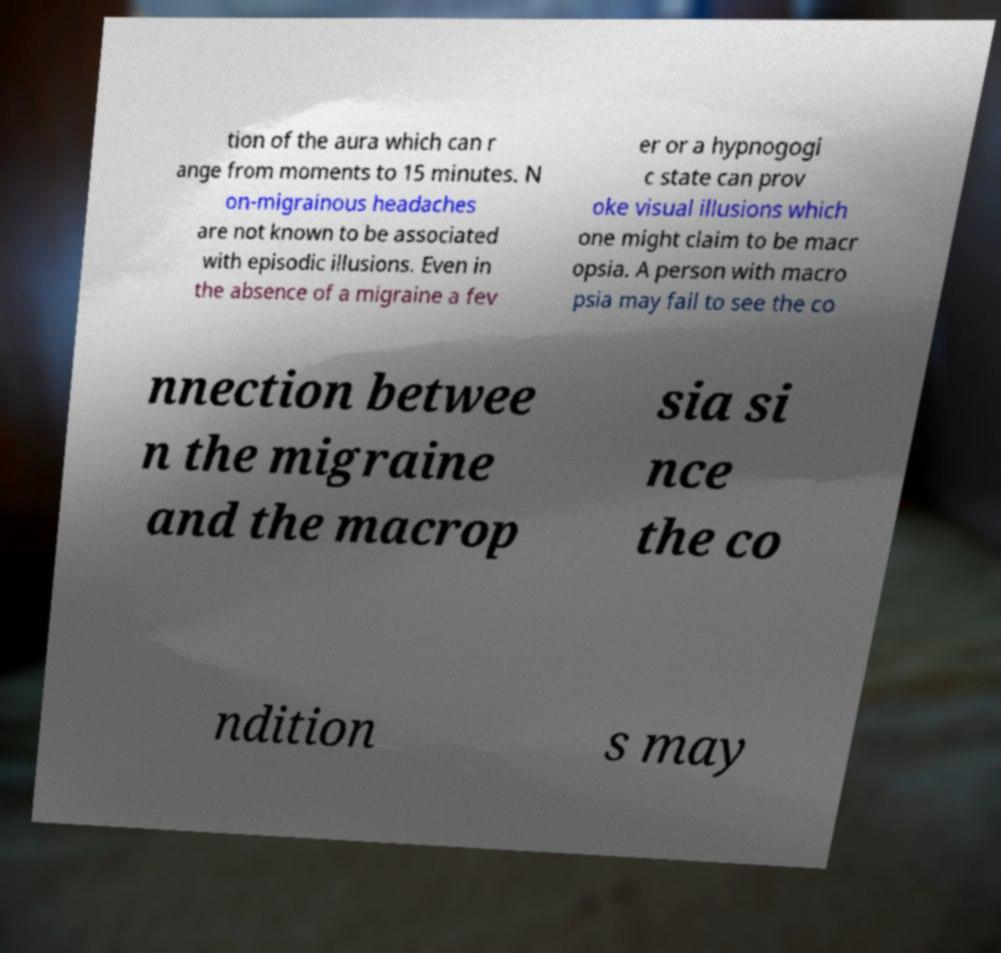Can you accurately transcribe the text from the provided image for me? tion of the aura which can r ange from moments to 15 minutes. N on-migrainous headaches are not known to be associated with episodic illusions. Even in the absence of a migraine a fev er or a hypnogogi c state can prov oke visual illusions which one might claim to be macr opsia. A person with macro psia may fail to see the co nnection betwee n the migraine and the macrop sia si nce the co ndition s may 